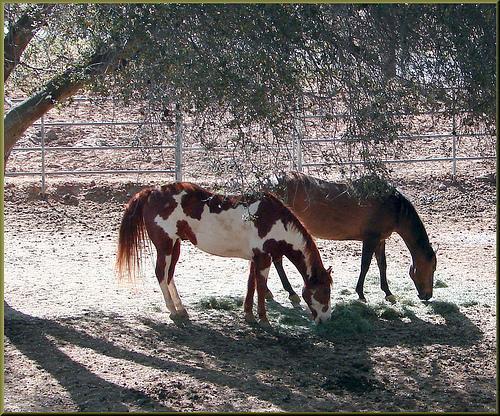How many horses are in the photo?
Give a very brief answer. 2. 